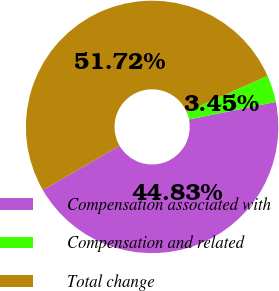Convert chart to OTSL. <chart><loc_0><loc_0><loc_500><loc_500><pie_chart><fcel>Compensation associated with<fcel>Compensation and related<fcel>Total change<nl><fcel>44.83%<fcel>3.45%<fcel>51.72%<nl></chart> 